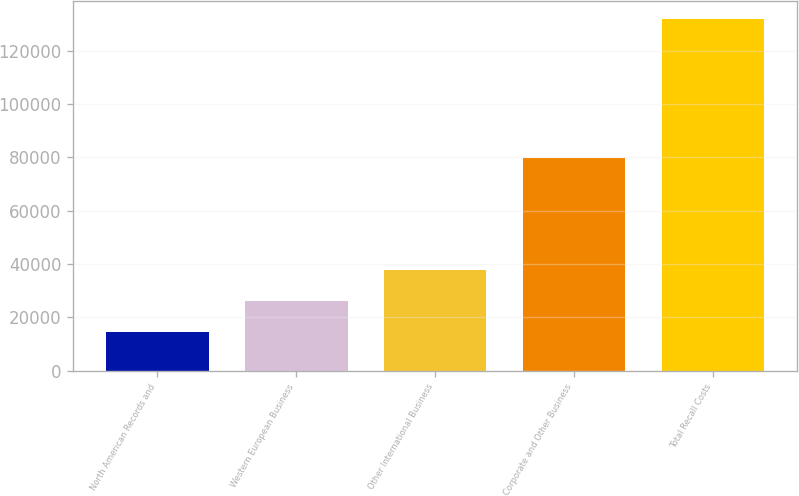Convert chart. <chart><loc_0><loc_0><loc_500><loc_500><bar_chart><fcel>North American Records and<fcel>Western European Business<fcel>Other International Business<fcel>Corporate and Other Business<fcel>Total Recall Costs<nl><fcel>14394<fcel>26149<fcel>37904<fcel>79954<fcel>131944<nl></chart> 